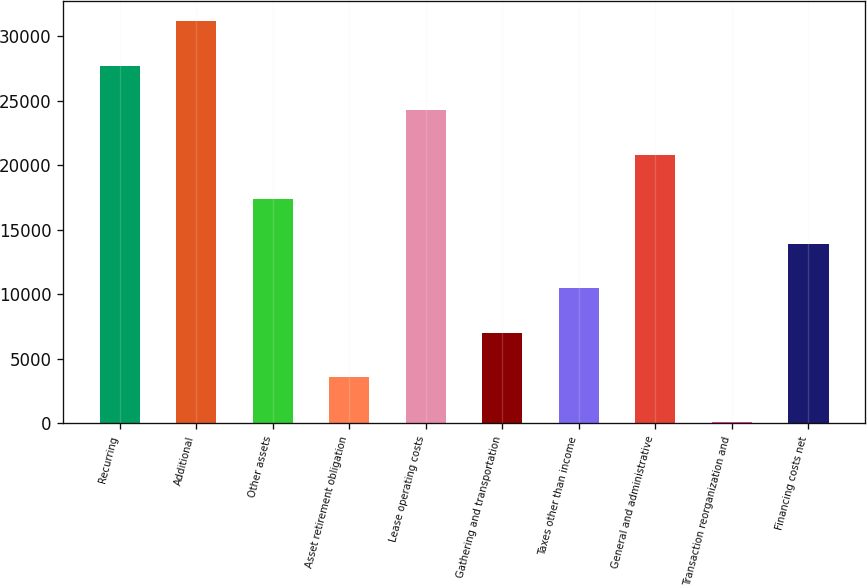Convert chart to OTSL. <chart><loc_0><loc_0><loc_500><loc_500><bar_chart><fcel>Recurring<fcel>Additional<fcel>Other assets<fcel>Asset retirement obligation<fcel>Lease operating costs<fcel>Gathering and transportation<fcel>Taxes other than income<fcel>General and administrative<fcel>Transaction reorganization and<fcel>Financing costs net<nl><fcel>27700<fcel>31146<fcel>17362<fcel>3578<fcel>24254<fcel>7024<fcel>10470<fcel>20808<fcel>132<fcel>13916<nl></chart> 